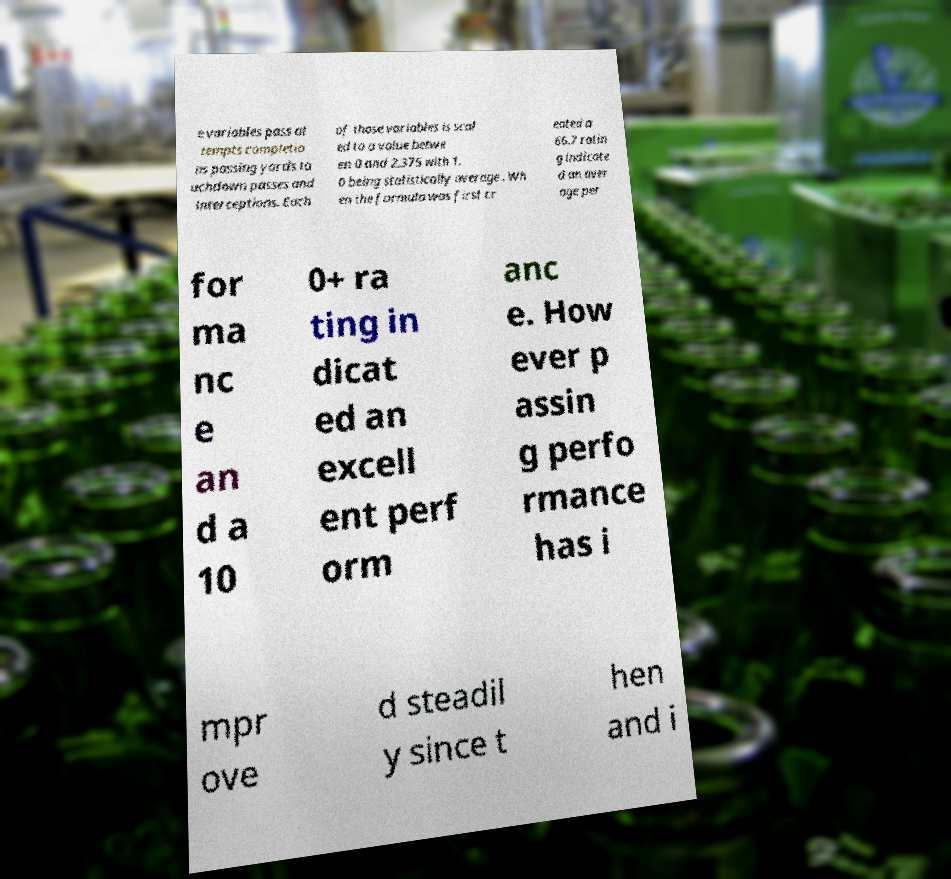I need the written content from this picture converted into text. Can you do that? e variables pass at tempts completio ns passing yards to uchdown passes and interceptions. Each of those variables is scal ed to a value betwe en 0 and 2.375 with 1. 0 being statistically average . Wh en the formula was first cr eated a 66.7 ratin g indicate d an aver age per for ma nc e an d a 10 0+ ra ting in dicat ed an excell ent perf orm anc e. How ever p assin g perfo rmance has i mpr ove d steadil y since t hen and i 